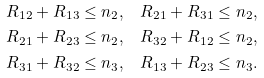Convert formula to latex. <formula><loc_0><loc_0><loc_500><loc_500>R _ { 1 2 } + R _ { 1 3 } \leq n _ { 2 } , & \quad R _ { 2 1 } + R _ { 3 1 } \leq n _ { 2 } , \\ R _ { 2 1 } + R _ { 2 3 } \leq n _ { 2 } , & \quad R _ { 3 2 } + R _ { 1 2 } \leq n _ { 2 } , \\ R _ { 3 1 } + R _ { 3 2 } \leq n _ { 3 } , & \quad R _ { 1 3 } + R _ { 2 3 } \leq n _ { 3 } .</formula> 